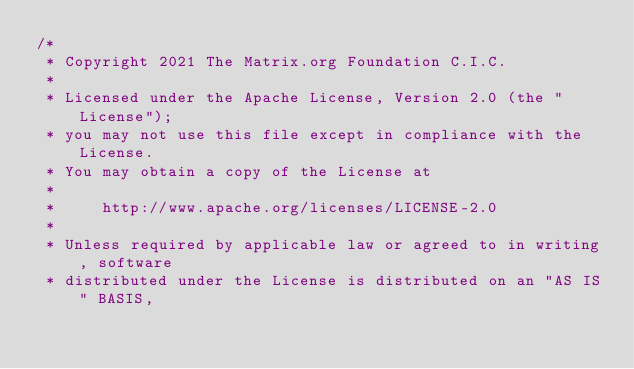Convert code to text. <code><loc_0><loc_0><loc_500><loc_500><_SQL_>/*
 * Copyright 2021 The Matrix.org Foundation C.I.C.
 *
 * Licensed under the Apache License, Version 2.0 (the "License");
 * you may not use this file except in compliance with the License.
 * You may obtain a copy of the License at
 *
 *     http://www.apache.org/licenses/LICENSE-2.0
 *
 * Unless required by applicable law or agreed to in writing, software
 * distributed under the License is distributed on an "AS IS" BASIS,</code> 